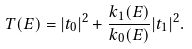<formula> <loc_0><loc_0><loc_500><loc_500>T ( E ) = | t _ { 0 } | ^ { 2 } + \frac { k _ { 1 } ( E ) } { k _ { 0 } ( E ) } | t _ { 1 } | ^ { 2 } .</formula> 